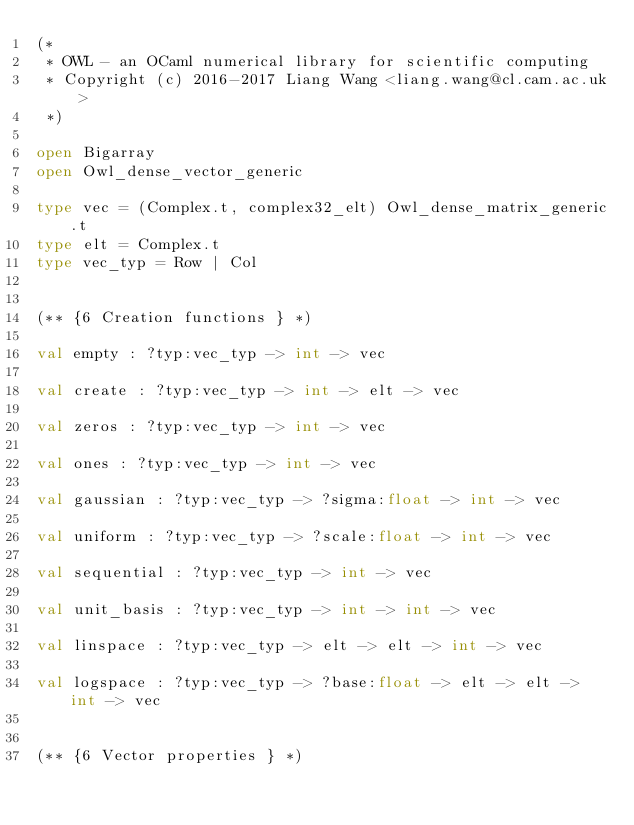<code> <loc_0><loc_0><loc_500><loc_500><_OCaml_>(*
 * OWL - an OCaml numerical library for scientific computing
 * Copyright (c) 2016-2017 Liang Wang <liang.wang@cl.cam.ac.uk>
 *)

open Bigarray
open Owl_dense_vector_generic

type vec = (Complex.t, complex32_elt) Owl_dense_matrix_generic.t
type elt = Complex.t
type vec_typ = Row | Col


(** {6 Creation functions } *)

val empty : ?typ:vec_typ -> int -> vec

val create : ?typ:vec_typ -> int -> elt -> vec

val zeros : ?typ:vec_typ -> int -> vec

val ones : ?typ:vec_typ -> int -> vec

val gaussian : ?typ:vec_typ -> ?sigma:float -> int -> vec

val uniform : ?typ:vec_typ -> ?scale:float -> int -> vec

val sequential : ?typ:vec_typ -> int -> vec

val unit_basis : ?typ:vec_typ -> int -> int -> vec

val linspace : ?typ:vec_typ -> elt -> elt -> int -> vec

val logspace : ?typ:vec_typ -> ?base:float -> elt -> elt -> int -> vec


(** {6 Vector properties } *)
</code> 